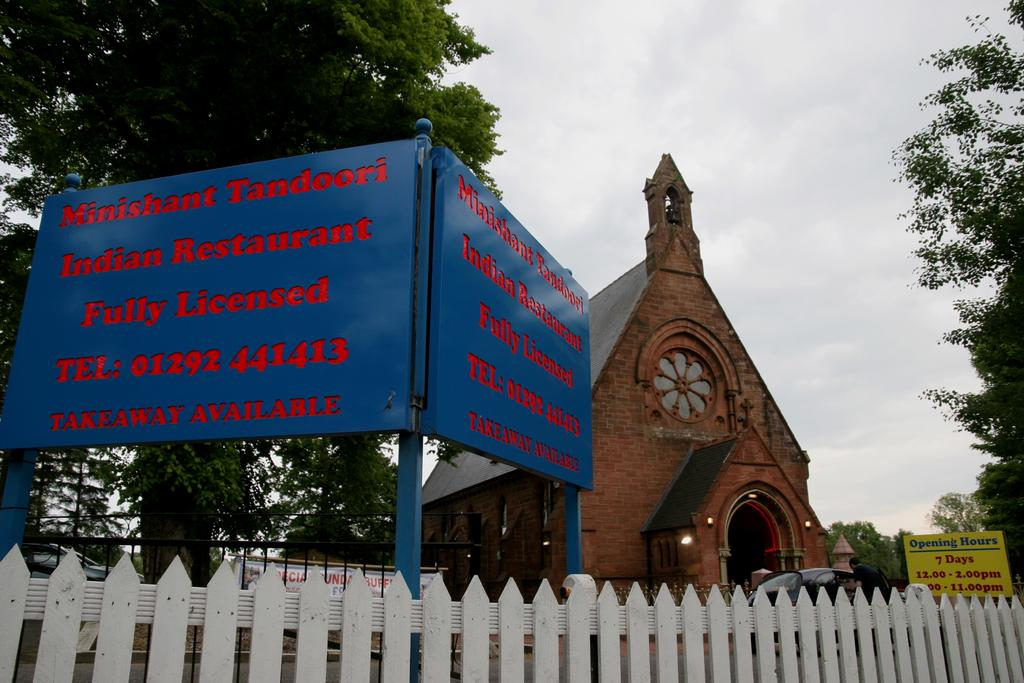What type of structure can be seen in the image? There is a fence in the image, as well as boards on poles, a banner, a person, cars, trees, lights, a building, and the sky visible in the background. Can you describe the setting of the image? The image features a fence, boards on poles, a banner, a person, cars, trees, lights, a building, and the sky visible in the background. What might be the purpose of the banner in the image? The purpose of the banner in the image is not explicitly stated, but it could be for advertising, promotion, or event information. How many types of structures are visible in the image? There are multiple types of structures visible in the image, including a fence, boards on poles, a banner, a person, cars, trees, lights, and a building. What type of tank is visible in the image? There is no tank present in the image. What rule is being enforced by the person in the image? There is no indication of a rule being enforced by the person in the image. 